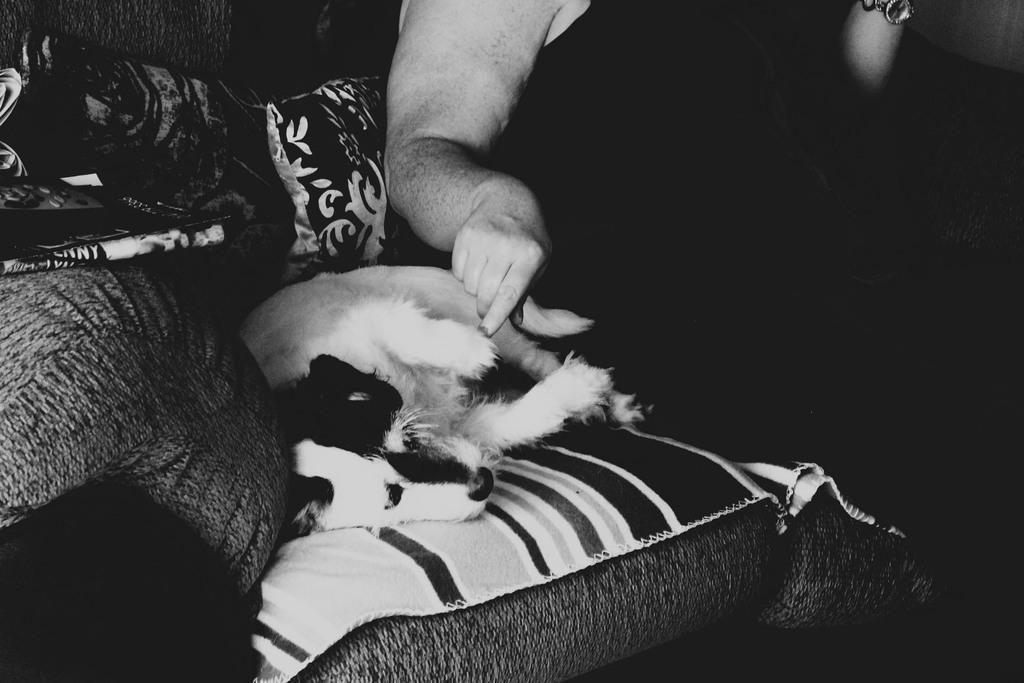How would you summarize this image in a sentence or two? In this image there is a person sitting on the sofa. Beside her there is a dog. There are pillows. 